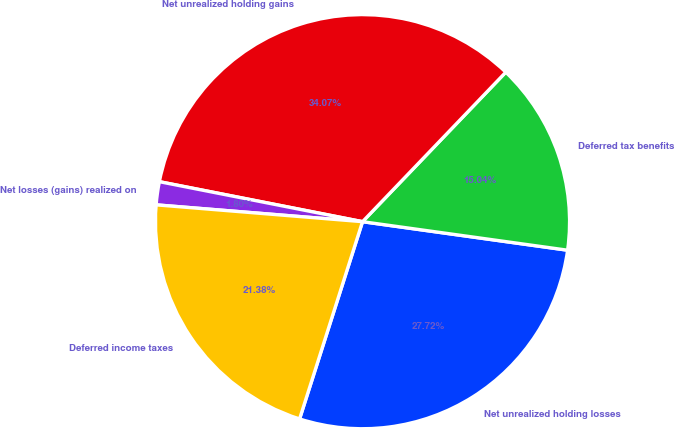Convert chart to OTSL. <chart><loc_0><loc_0><loc_500><loc_500><pie_chart><fcel>Net unrealized holding losses<fcel>Deferred tax benefits<fcel>Net unrealized holding gains<fcel>Net losses (gains) realized on<fcel>Deferred income taxes<nl><fcel>27.72%<fcel>15.04%<fcel>34.07%<fcel>1.8%<fcel>21.38%<nl></chart> 